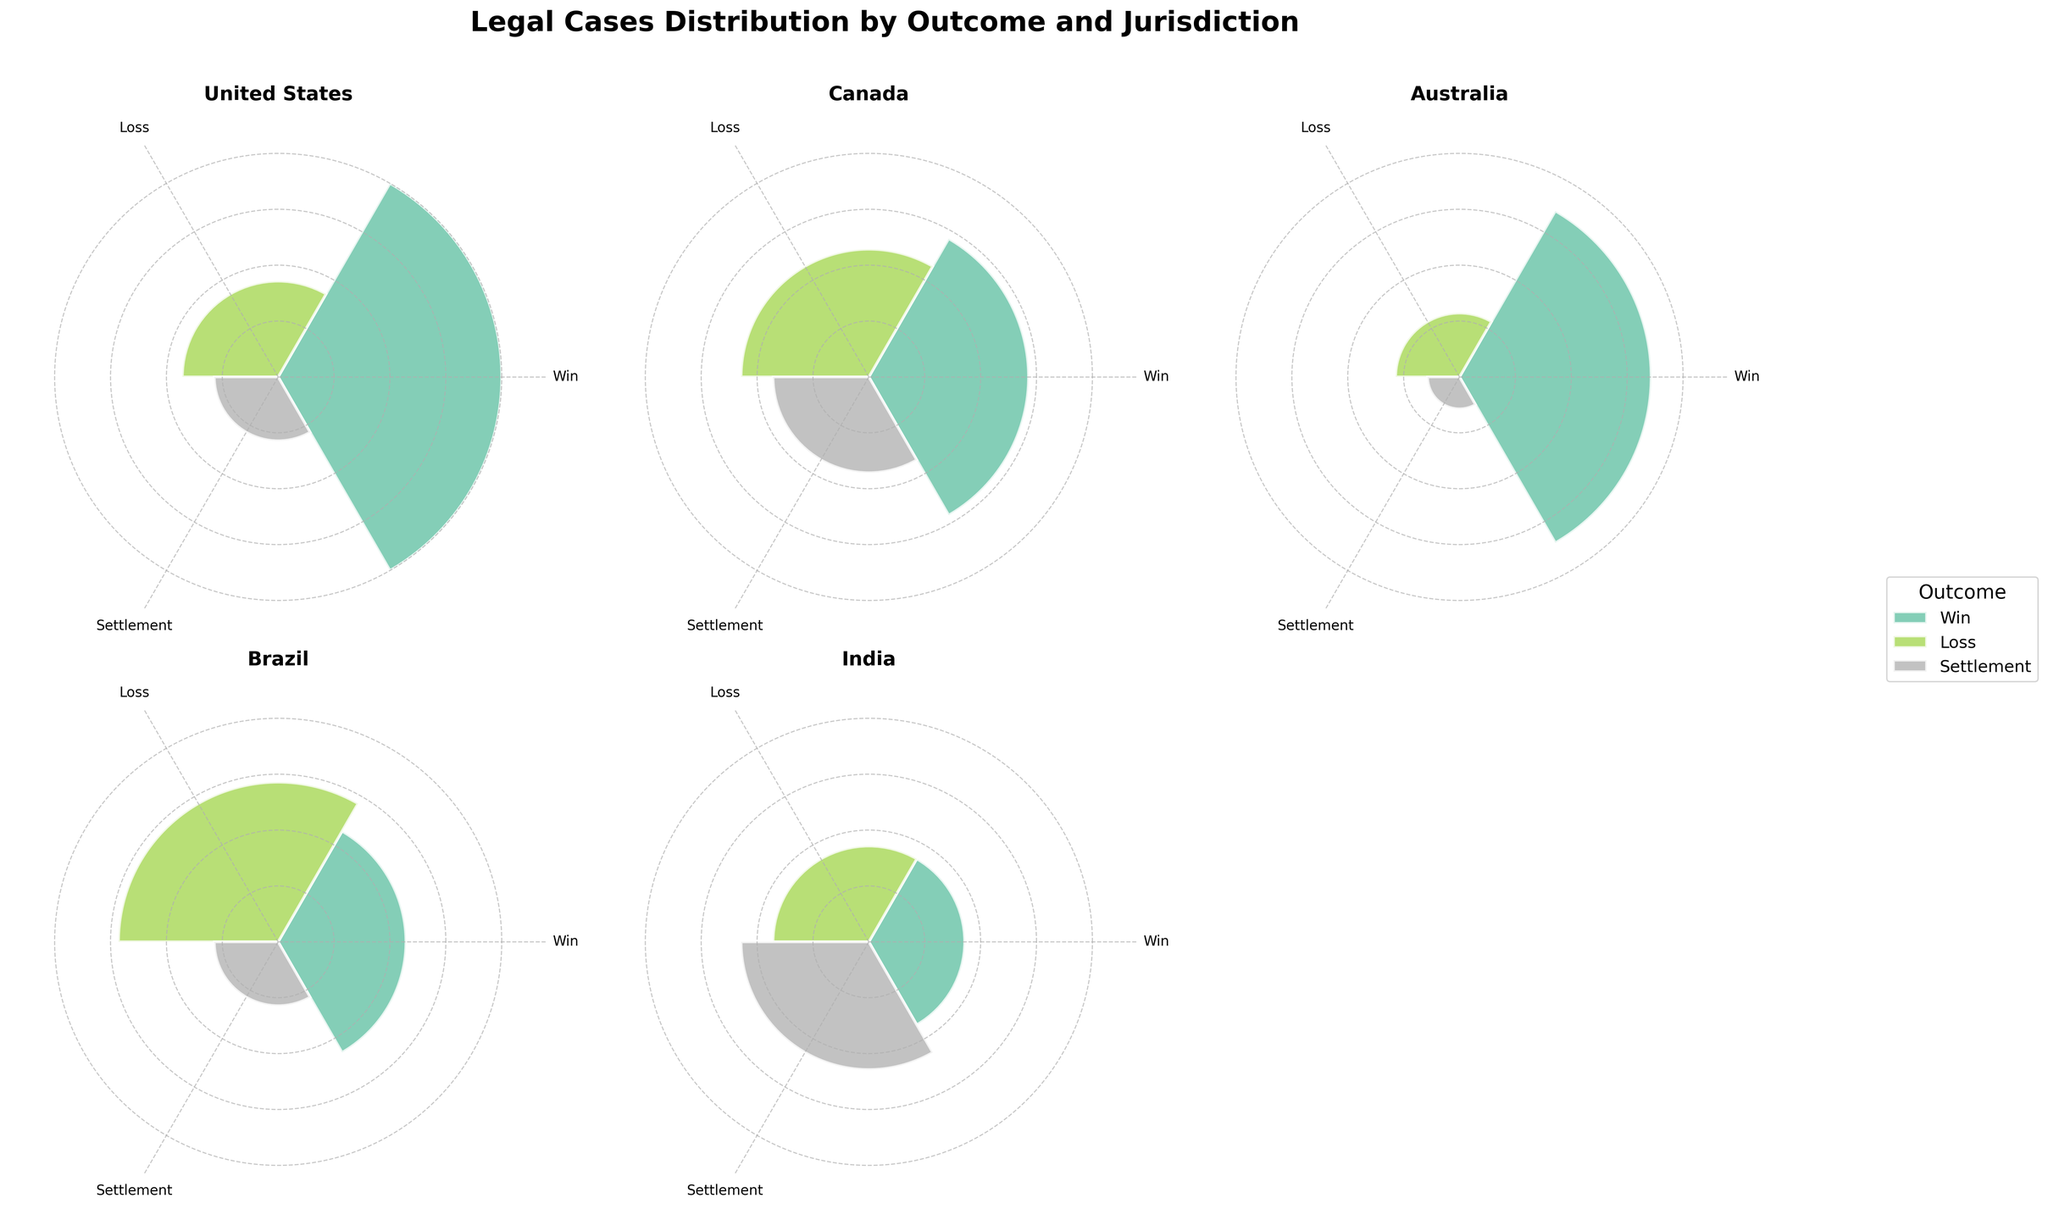What's the title of the figure? The title of the figure is prominently displayed at the top center of the figure. It reads "Legal Cases Distribution by Outcome and Jurisdiction."
Answer: Legal Cases Distribution by Outcome and Jurisdiction How many jurisdictions are shown in the figure? Each subplot represents one jurisdiction, and there are 5 subplots in total.
Answer: 5 Which jurisdiction has the highest number of wins? By visually inspecting each subplot and comparing the bars for 'Win', the United States has the tallest bar in the 'Win' category.
Answer: United States Which outcome has the highest case count in India? In the India subplot, the bar for 'Settlement' is the tallest among the three outcomes.
Answer: Settlement What is the total number of cases in Canada? Summing up the case counts for all outcomes in Canada: 25 (Win) + 20 (Loss) + 15 (Settlement) = 60
Answer: 60 In which jurisdiction is the 'Loss' outcome more frequent than the 'Win' outcome? By comparing the heights of 'Loss' and 'Win' bars in each subplot, Brazil has a higher 'Loss' count (25) compared to 'Win' (20).
Answer: Brazil How many more 'Win' cases are there compared to 'Loss' cases in Australia? In Australia, the 'Win' count is 30 and the 'Loss' count is 10. The difference is 30 - 10 = 20.
Answer: 20 Which jurisdiction has the most balanced distribution among outcomes? By visually comparing the relative heights of the bars for each outcome in each subplot, India has bars of relatively similar heights (15, 15, 20).
Answer: India What is the average number of 'Settlement' cases across all jurisdictions? Sum the 'Settlement' cases in all jurisdictions: 10 (US) + 15 (Canada) + 5 (Australia) + 10 (Brazil) + 20 (India) = 60; average = 60 / 5 = 12.
Answer: 12 Which jurisdiction has the least 'Settlement' cases? By examining the 'Settlement' bars in each subplot, Australia has the shortest 'Settlement' bar with a value of 5.
Answer: Australia 